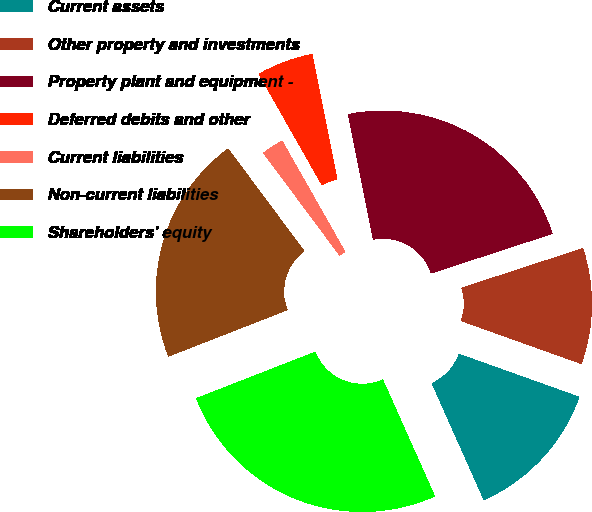<chart> <loc_0><loc_0><loc_500><loc_500><pie_chart><fcel>Current assets<fcel>Other property and investments<fcel>Property plant and equipment -<fcel>Deferred debits and other<fcel>Current liabilities<fcel>Non-current liabilities<fcel>Shareholders' equity<nl><fcel>12.86%<fcel>10.48%<fcel>23.12%<fcel>5.07%<fcel>1.96%<fcel>20.74%<fcel>25.75%<nl></chart> 